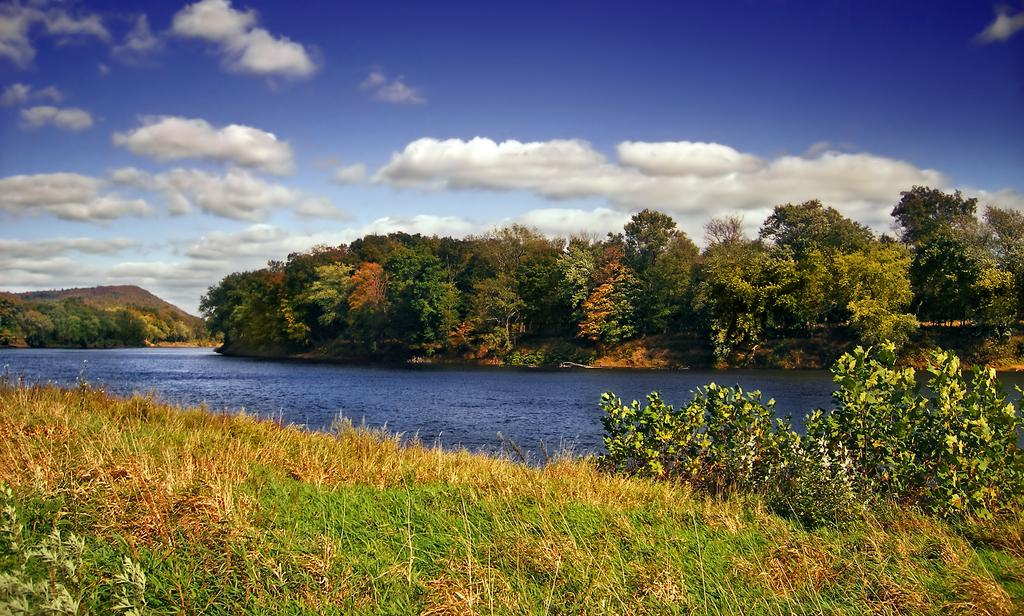What type of natural environment is depicted in the image? The image contains water, grass, trees, and plants, which suggests a natural environment. What type of landform can be seen in the image? There is a hill in the image. What is the condition of the sky in the image? The sky is cloudy in the image. What direction is the territory expanding towards in the image? There is no indication of a territory or its expansion in the image. How does the water pull the hill in the image? The water does not pull the hill in the image; the hill and water are stationary in the image. 